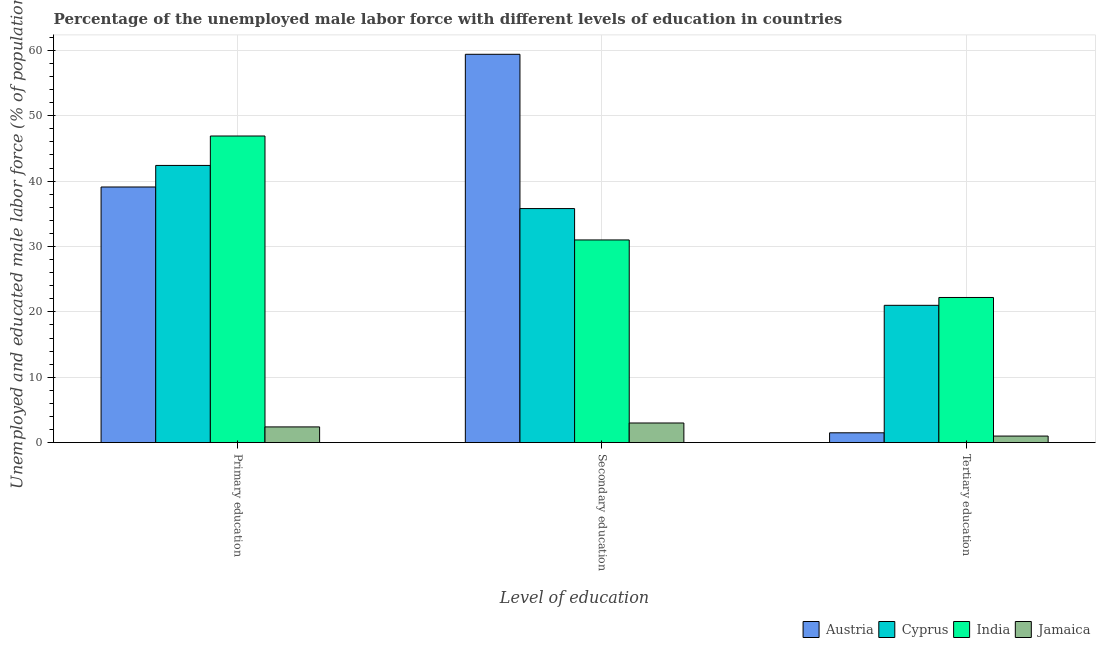How many different coloured bars are there?
Keep it short and to the point. 4. Are the number of bars on each tick of the X-axis equal?
Make the answer very short. Yes. How many bars are there on the 3rd tick from the left?
Your answer should be very brief. 4. How many bars are there on the 1st tick from the right?
Make the answer very short. 4. What is the label of the 2nd group of bars from the left?
Keep it short and to the point. Secondary education. What is the percentage of male labor force who received primary education in Cyprus?
Your response must be concise. 42.4. Across all countries, what is the maximum percentage of male labor force who received tertiary education?
Your answer should be compact. 22.2. In which country was the percentage of male labor force who received tertiary education maximum?
Your response must be concise. India. In which country was the percentage of male labor force who received tertiary education minimum?
Make the answer very short. Jamaica. What is the total percentage of male labor force who received secondary education in the graph?
Your answer should be compact. 129.2. What is the difference between the percentage of male labor force who received tertiary education in India and that in Austria?
Provide a short and direct response. 20.7. What is the average percentage of male labor force who received tertiary education per country?
Give a very brief answer. 11.43. What is the difference between the percentage of male labor force who received primary education and percentage of male labor force who received tertiary education in Jamaica?
Provide a succinct answer. 1.4. What is the ratio of the percentage of male labor force who received tertiary education in India to that in Jamaica?
Offer a terse response. 22.2. Is the percentage of male labor force who received tertiary education in Cyprus less than that in Jamaica?
Make the answer very short. No. What is the difference between the highest and the second highest percentage of male labor force who received secondary education?
Provide a succinct answer. 23.6. What is the difference between the highest and the lowest percentage of male labor force who received primary education?
Your response must be concise. 44.5. In how many countries, is the percentage of male labor force who received secondary education greater than the average percentage of male labor force who received secondary education taken over all countries?
Make the answer very short. 2. Is the sum of the percentage of male labor force who received secondary education in Cyprus and Austria greater than the maximum percentage of male labor force who received primary education across all countries?
Your answer should be compact. Yes. What does the 3rd bar from the right in Primary education represents?
Ensure brevity in your answer.  Cyprus. How many bars are there?
Make the answer very short. 12. How many countries are there in the graph?
Your response must be concise. 4. Are the values on the major ticks of Y-axis written in scientific E-notation?
Provide a short and direct response. No. Does the graph contain any zero values?
Provide a succinct answer. No. Does the graph contain grids?
Ensure brevity in your answer.  Yes. Where does the legend appear in the graph?
Your response must be concise. Bottom right. What is the title of the graph?
Make the answer very short. Percentage of the unemployed male labor force with different levels of education in countries. What is the label or title of the X-axis?
Provide a short and direct response. Level of education. What is the label or title of the Y-axis?
Ensure brevity in your answer.  Unemployed and educated male labor force (% of population). What is the Unemployed and educated male labor force (% of population) of Austria in Primary education?
Your answer should be compact. 39.1. What is the Unemployed and educated male labor force (% of population) in Cyprus in Primary education?
Make the answer very short. 42.4. What is the Unemployed and educated male labor force (% of population) in India in Primary education?
Make the answer very short. 46.9. What is the Unemployed and educated male labor force (% of population) in Jamaica in Primary education?
Ensure brevity in your answer.  2.4. What is the Unemployed and educated male labor force (% of population) in Austria in Secondary education?
Provide a short and direct response. 59.4. What is the Unemployed and educated male labor force (% of population) in Cyprus in Secondary education?
Keep it short and to the point. 35.8. What is the Unemployed and educated male labor force (% of population) of India in Secondary education?
Make the answer very short. 31. What is the Unemployed and educated male labor force (% of population) of Jamaica in Secondary education?
Your answer should be compact. 3. What is the Unemployed and educated male labor force (% of population) in Austria in Tertiary education?
Give a very brief answer. 1.5. What is the Unemployed and educated male labor force (% of population) of Cyprus in Tertiary education?
Your response must be concise. 21. What is the Unemployed and educated male labor force (% of population) of India in Tertiary education?
Provide a succinct answer. 22.2. What is the Unemployed and educated male labor force (% of population) of Jamaica in Tertiary education?
Your answer should be very brief. 1. Across all Level of education, what is the maximum Unemployed and educated male labor force (% of population) in Austria?
Ensure brevity in your answer.  59.4. Across all Level of education, what is the maximum Unemployed and educated male labor force (% of population) of Cyprus?
Give a very brief answer. 42.4. Across all Level of education, what is the maximum Unemployed and educated male labor force (% of population) in India?
Provide a succinct answer. 46.9. Across all Level of education, what is the maximum Unemployed and educated male labor force (% of population) of Jamaica?
Give a very brief answer. 3. Across all Level of education, what is the minimum Unemployed and educated male labor force (% of population) of Austria?
Offer a very short reply. 1.5. Across all Level of education, what is the minimum Unemployed and educated male labor force (% of population) in Cyprus?
Provide a short and direct response. 21. Across all Level of education, what is the minimum Unemployed and educated male labor force (% of population) in India?
Offer a very short reply. 22.2. What is the total Unemployed and educated male labor force (% of population) in Cyprus in the graph?
Give a very brief answer. 99.2. What is the total Unemployed and educated male labor force (% of population) of India in the graph?
Provide a succinct answer. 100.1. What is the total Unemployed and educated male labor force (% of population) of Jamaica in the graph?
Provide a short and direct response. 6.4. What is the difference between the Unemployed and educated male labor force (% of population) of Austria in Primary education and that in Secondary education?
Your response must be concise. -20.3. What is the difference between the Unemployed and educated male labor force (% of population) in Cyprus in Primary education and that in Secondary education?
Your answer should be very brief. 6.6. What is the difference between the Unemployed and educated male labor force (% of population) in Austria in Primary education and that in Tertiary education?
Keep it short and to the point. 37.6. What is the difference between the Unemployed and educated male labor force (% of population) in Cyprus in Primary education and that in Tertiary education?
Keep it short and to the point. 21.4. What is the difference between the Unemployed and educated male labor force (% of population) of India in Primary education and that in Tertiary education?
Give a very brief answer. 24.7. What is the difference between the Unemployed and educated male labor force (% of population) in Jamaica in Primary education and that in Tertiary education?
Make the answer very short. 1.4. What is the difference between the Unemployed and educated male labor force (% of population) in Austria in Secondary education and that in Tertiary education?
Offer a terse response. 57.9. What is the difference between the Unemployed and educated male labor force (% of population) in Cyprus in Secondary education and that in Tertiary education?
Make the answer very short. 14.8. What is the difference between the Unemployed and educated male labor force (% of population) of India in Secondary education and that in Tertiary education?
Provide a succinct answer. 8.8. What is the difference between the Unemployed and educated male labor force (% of population) of Jamaica in Secondary education and that in Tertiary education?
Provide a succinct answer. 2. What is the difference between the Unemployed and educated male labor force (% of population) in Austria in Primary education and the Unemployed and educated male labor force (% of population) in Jamaica in Secondary education?
Offer a terse response. 36.1. What is the difference between the Unemployed and educated male labor force (% of population) of Cyprus in Primary education and the Unemployed and educated male labor force (% of population) of Jamaica in Secondary education?
Keep it short and to the point. 39.4. What is the difference between the Unemployed and educated male labor force (% of population) of India in Primary education and the Unemployed and educated male labor force (% of population) of Jamaica in Secondary education?
Offer a terse response. 43.9. What is the difference between the Unemployed and educated male labor force (% of population) in Austria in Primary education and the Unemployed and educated male labor force (% of population) in India in Tertiary education?
Provide a succinct answer. 16.9. What is the difference between the Unemployed and educated male labor force (% of population) of Austria in Primary education and the Unemployed and educated male labor force (% of population) of Jamaica in Tertiary education?
Provide a short and direct response. 38.1. What is the difference between the Unemployed and educated male labor force (% of population) of Cyprus in Primary education and the Unemployed and educated male labor force (% of population) of India in Tertiary education?
Your answer should be very brief. 20.2. What is the difference between the Unemployed and educated male labor force (% of population) in Cyprus in Primary education and the Unemployed and educated male labor force (% of population) in Jamaica in Tertiary education?
Your answer should be compact. 41.4. What is the difference between the Unemployed and educated male labor force (% of population) in India in Primary education and the Unemployed and educated male labor force (% of population) in Jamaica in Tertiary education?
Your answer should be very brief. 45.9. What is the difference between the Unemployed and educated male labor force (% of population) of Austria in Secondary education and the Unemployed and educated male labor force (% of population) of Cyprus in Tertiary education?
Keep it short and to the point. 38.4. What is the difference between the Unemployed and educated male labor force (% of population) of Austria in Secondary education and the Unemployed and educated male labor force (% of population) of India in Tertiary education?
Your response must be concise. 37.2. What is the difference between the Unemployed and educated male labor force (% of population) of Austria in Secondary education and the Unemployed and educated male labor force (% of population) of Jamaica in Tertiary education?
Make the answer very short. 58.4. What is the difference between the Unemployed and educated male labor force (% of population) in Cyprus in Secondary education and the Unemployed and educated male labor force (% of population) in India in Tertiary education?
Offer a terse response. 13.6. What is the difference between the Unemployed and educated male labor force (% of population) in Cyprus in Secondary education and the Unemployed and educated male labor force (% of population) in Jamaica in Tertiary education?
Your answer should be compact. 34.8. What is the average Unemployed and educated male labor force (% of population) of Austria per Level of education?
Your response must be concise. 33.33. What is the average Unemployed and educated male labor force (% of population) of Cyprus per Level of education?
Ensure brevity in your answer.  33.07. What is the average Unemployed and educated male labor force (% of population) of India per Level of education?
Make the answer very short. 33.37. What is the average Unemployed and educated male labor force (% of population) in Jamaica per Level of education?
Make the answer very short. 2.13. What is the difference between the Unemployed and educated male labor force (% of population) of Austria and Unemployed and educated male labor force (% of population) of Cyprus in Primary education?
Offer a terse response. -3.3. What is the difference between the Unemployed and educated male labor force (% of population) of Austria and Unemployed and educated male labor force (% of population) of Jamaica in Primary education?
Give a very brief answer. 36.7. What is the difference between the Unemployed and educated male labor force (% of population) in Cyprus and Unemployed and educated male labor force (% of population) in India in Primary education?
Keep it short and to the point. -4.5. What is the difference between the Unemployed and educated male labor force (% of population) in Cyprus and Unemployed and educated male labor force (% of population) in Jamaica in Primary education?
Ensure brevity in your answer.  40. What is the difference between the Unemployed and educated male labor force (% of population) in India and Unemployed and educated male labor force (% of population) in Jamaica in Primary education?
Your answer should be compact. 44.5. What is the difference between the Unemployed and educated male labor force (% of population) of Austria and Unemployed and educated male labor force (% of population) of Cyprus in Secondary education?
Provide a short and direct response. 23.6. What is the difference between the Unemployed and educated male labor force (% of population) of Austria and Unemployed and educated male labor force (% of population) of India in Secondary education?
Provide a short and direct response. 28.4. What is the difference between the Unemployed and educated male labor force (% of population) in Austria and Unemployed and educated male labor force (% of population) in Jamaica in Secondary education?
Provide a succinct answer. 56.4. What is the difference between the Unemployed and educated male labor force (% of population) of Cyprus and Unemployed and educated male labor force (% of population) of India in Secondary education?
Make the answer very short. 4.8. What is the difference between the Unemployed and educated male labor force (% of population) in Cyprus and Unemployed and educated male labor force (% of population) in Jamaica in Secondary education?
Offer a terse response. 32.8. What is the difference between the Unemployed and educated male labor force (% of population) in India and Unemployed and educated male labor force (% of population) in Jamaica in Secondary education?
Your response must be concise. 28. What is the difference between the Unemployed and educated male labor force (% of population) in Austria and Unemployed and educated male labor force (% of population) in Cyprus in Tertiary education?
Provide a succinct answer. -19.5. What is the difference between the Unemployed and educated male labor force (% of population) in Austria and Unemployed and educated male labor force (% of population) in India in Tertiary education?
Offer a very short reply. -20.7. What is the difference between the Unemployed and educated male labor force (% of population) in Austria and Unemployed and educated male labor force (% of population) in Jamaica in Tertiary education?
Provide a short and direct response. 0.5. What is the difference between the Unemployed and educated male labor force (% of population) in Cyprus and Unemployed and educated male labor force (% of population) in India in Tertiary education?
Offer a terse response. -1.2. What is the difference between the Unemployed and educated male labor force (% of population) of India and Unemployed and educated male labor force (% of population) of Jamaica in Tertiary education?
Your answer should be compact. 21.2. What is the ratio of the Unemployed and educated male labor force (% of population) in Austria in Primary education to that in Secondary education?
Offer a very short reply. 0.66. What is the ratio of the Unemployed and educated male labor force (% of population) in Cyprus in Primary education to that in Secondary education?
Keep it short and to the point. 1.18. What is the ratio of the Unemployed and educated male labor force (% of population) of India in Primary education to that in Secondary education?
Provide a short and direct response. 1.51. What is the ratio of the Unemployed and educated male labor force (% of population) of Austria in Primary education to that in Tertiary education?
Offer a very short reply. 26.07. What is the ratio of the Unemployed and educated male labor force (% of population) in Cyprus in Primary education to that in Tertiary education?
Make the answer very short. 2.02. What is the ratio of the Unemployed and educated male labor force (% of population) in India in Primary education to that in Tertiary education?
Your answer should be compact. 2.11. What is the ratio of the Unemployed and educated male labor force (% of population) of Jamaica in Primary education to that in Tertiary education?
Keep it short and to the point. 2.4. What is the ratio of the Unemployed and educated male labor force (% of population) in Austria in Secondary education to that in Tertiary education?
Provide a succinct answer. 39.6. What is the ratio of the Unemployed and educated male labor force (% of population) in Cyprus in Secondary education to that in Tertiary education?
Ensure brevity in your answer.  1.7. What is the ratio of the Unemployed and educated male labor force (% of population) in India in Secondary education to that in Tertiary education?
Your answer should be very brief. 1.4. What is the ratio of the Unemployed and educated male labor force (% of population) in Jamaica in Secondary education to that in Tertiary education?
Ensure brevity in your answer.  3. What is the difference between the highest and the second highest Unemployed and educated male labor force (% of population) of Austria?
Your response must be concise. 20.3. What is the difference between the highest and the second highest Unemployed and educated male labor force (% of population) of Cyprus?
Keep it short and to the point. 6.6. What is the difference between the highest and the lowest Unemployed and educated male labor force (% of population) of Austria?
Offer a very short reply. 57.9. What is the difference between the highest and the lowest Unemployed and educated male labor force (% of population) of Cyprus?
Provide a succinct answer. 21.4. What is the difference between the highest and the lowest Unemployed and educated male labor force (% of population) of India?
Your response must be concise. 24.7. What is the difference between the highest and the lowest Unemployed and educated male labor force (% of population) of Jamaica?
Offer a very short reply. 2. 